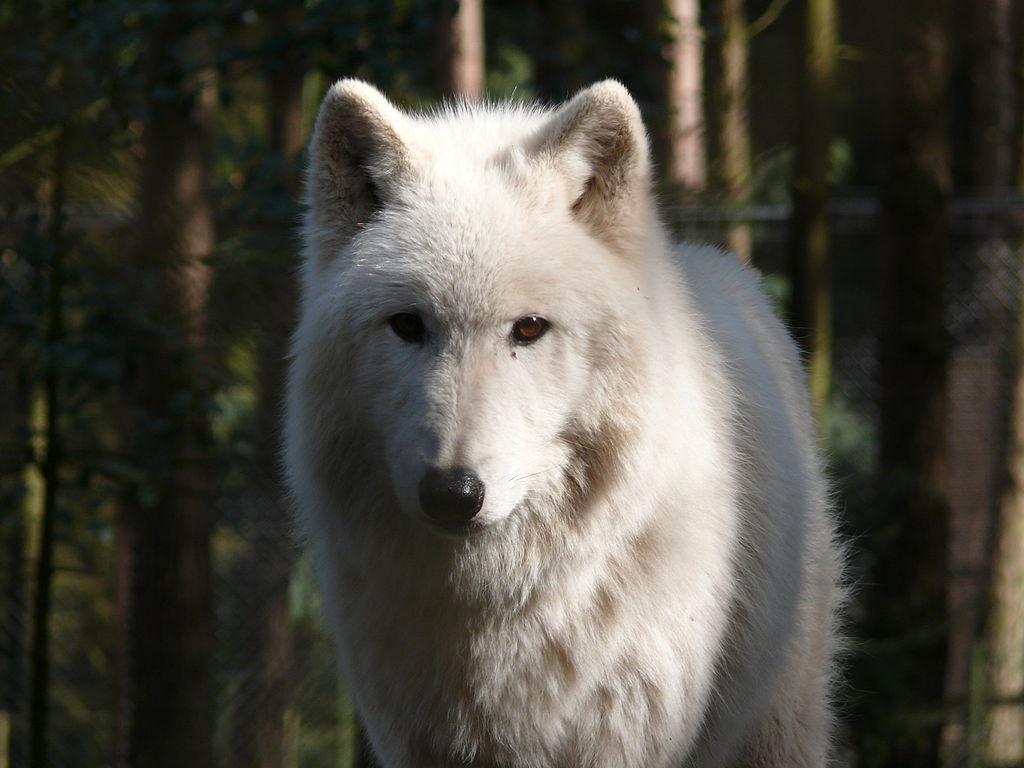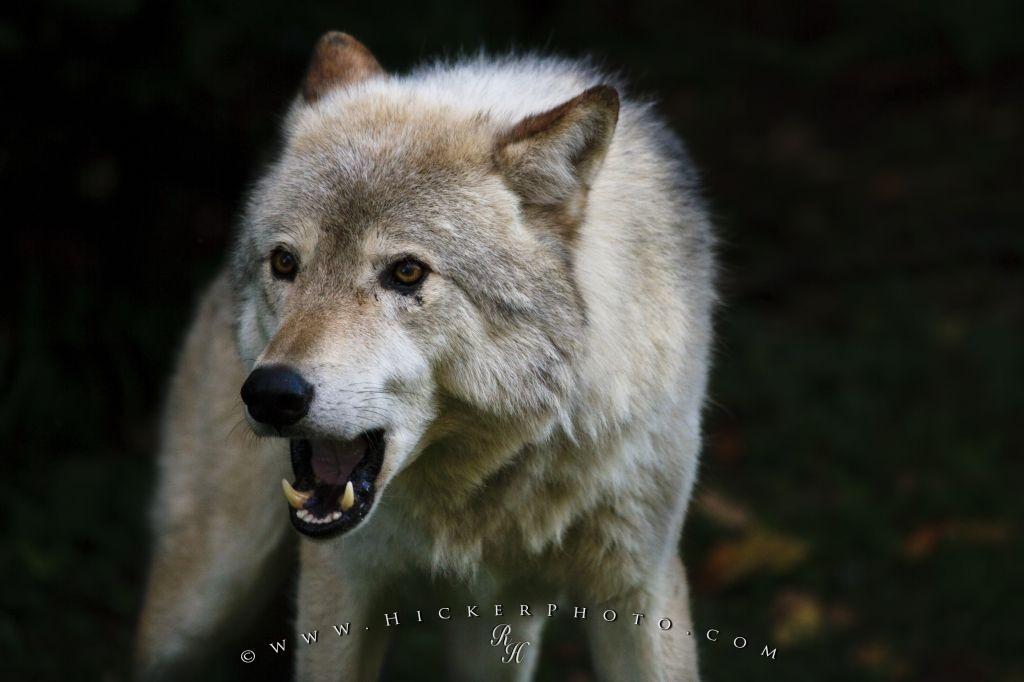The first image is the image on the left, the second image is the image on the right. Analyze the images presented: Is the assertion "There are two wolves" valid? Answer yes or no. Yes. The first image is the image on the left, the second image is the image on the right. Given the left and right images, does the statement "All images show exactly one wolf." hold true? Answer yes or no. Yes. 